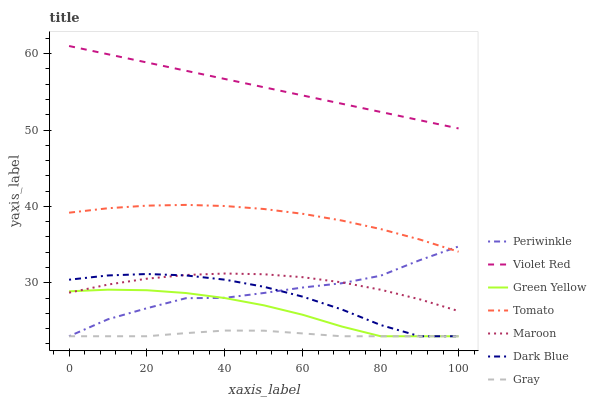Does Gray have the minimum area under the curve?
Answer yes or no. Yes. Does Violet Red have the maximum area under the curve?
Answer yes or no. Yes. Does Violet Red have the minimum area under the curve?
Answer yes or no. No. Does Gray have the maximum area under the curve?
Answer yes or no. No. Is Violet Red the smoothest?
Answer yes or no. Yes. Is Periwinkle the roughest?
Answer yes or no. Yes. Is Gray the smoothest?
Answer yes or no. No. Is Gray the roughest?
Answer yes or no. No. Does Gray have the lowest value?
Answer yes or no. Yes. Does Violet Red have the lowest value?
Answer yes or no. No. Does Violet Red have the highest value?
Answer yes or no. Yes. Does Gray have the highest value?
Answer yes or no. No. Is Maroon less than Tomato?
Answer yes or no. Yes. Is Violet Red greater than Dark Blue?
Answer yes or no. Yes. Does Dark Blue intersect Maroon?
Answer yes or no. Yes. Is Dark Blue less than Maroon?
Answer yes or no. No. Is Dark Blue greater than Maroon?
Answer yes or no. No. Does Maroon intersect Tomato?
Answer yes or no. No. 